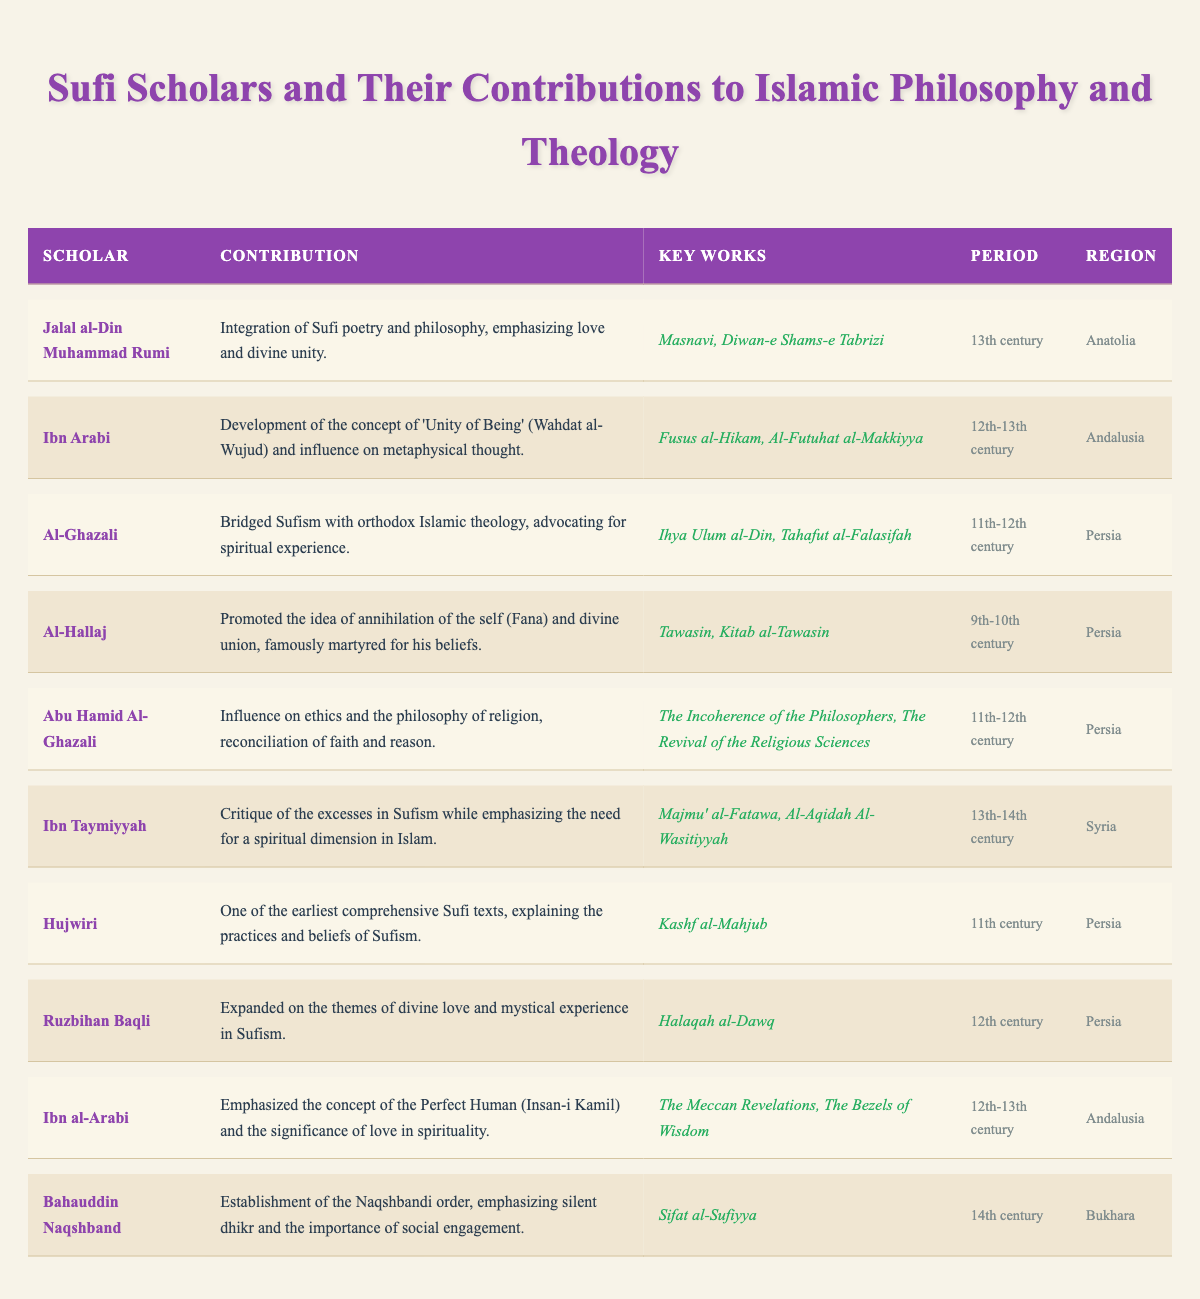What contributions did Jalal al-Din Muhammad Rumi make to Islamic philosophy? He integrated Sufi poetry and philosophy and emphasized love and divine unity, as stated in his contribution in the table.
Answer: Integration of Sufi poetry and philosophy, emphasizing love and divine unity Which scholar developed the concept of 'Unity of Being'? Ibn Arabi developed the concept of 'Unity of Being' (Wahdat al-Wujud), which is mentioned in the contribution section of the table.
Answer: Ibn Arabi How many scholars contributed in the 12th century? The scholars from the 12th century are Ibn Arabi, Ruzbihan Baqli, and Ibn al-Arabi, summing up to three scholars.
Answer: 3 Did Al-Ghazali advocate for spiritual experience? Yes, Al-Ghazali is noted for bridging Sufism with orthodox Islamic theology and advocating for spiritual experience, confirming a 'yes'.
Answer: Yes What is the relationship between the periods of Al-Hallaj and Ibn Taymiyyah? Al-Hallaj's period (9th-10th century) is earlier than Ibn Taymiyyah's period (13th-14th century), indicating that Al-Hallaj lived before Ibn Taymiyyah.
Answer: Al-Hallaj lived earlier Which scholar emphasized silent dhikr and social engagement? Bahauddin Naqshband is noted for the establishment of the Naqshbandi order, emphasizing silent dhikr and social engagement according to the table.
Answer: Bahauddin Naqshband What are the key works of Hujwiri? Hujwiri authored "Kashf al-Mahjub" as listed in the key works section of the table.
Answer: Kashf al-Mahjub How many scholars from Persia are included in the table? Upon reviewing the table, the scholars from Persia are Al-Ghazali, Al-Hallaj, Abu Hamid Al-Ghazali, Hujwiri, Ruzbihan Baqli, making a total of five scholars.
Answer: 5 What was the primary focus of Ibn Taymiyyah’s critiques? Ibn Taymiyyah critiqued the excesses in Sufism while emphasizing a spiritual dimension, as stated in the table.
Answer: Excesses in Sufism Which scholar's work includes the "Masnavi"? Jalal al-Din Muhammad Rumi is noted for his work "Masnavi," as per the key works section in the table.
Answer: Jalal al-Din Muhammad Rumi List all scholars who lived in the 11th century. The scholars who lived during the 11th century include Al-Ghazali, Abu Hamid Al-Ghazali, and Hujwiri, consolidating to three individuals.
Answer: 3 